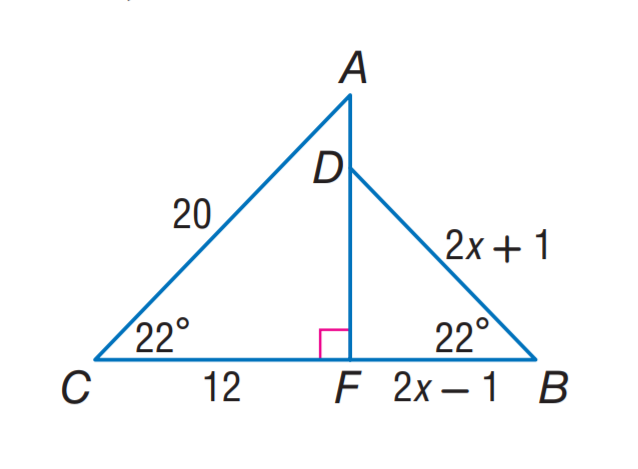Question: Find C B.
Choices:
A. 5
B. 12
C. 15
D. 20
Answer with the letter. Answer: C Question: Find D B.
Choices:
A. 3
B. 5
C. 12
D. 15
Answer with the letter. Answer: B 